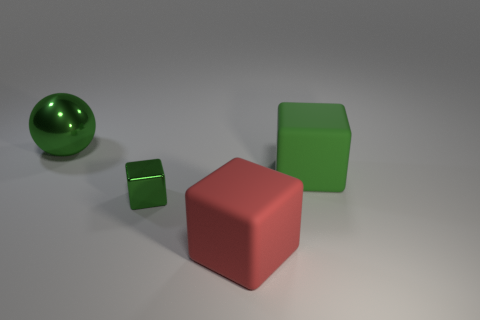Subtract all green blocks. How many blocks are left? 1 Add 1 green cubes. How many objects exist? 5 Subtract all blue cylinders. How many green cubes are left? 2 Subtract all balls. How many objects are left? 3 Subtract all red cubes. How many cubes are left? 2 Add 4 tiny yellow metallic cylinders. How many tiny yellow metallic cylinders exist? 4 Subtract 0 green cylinders. How many objects are left? 4 Subtract all brown balls. Subtract all cyan cylinders. How many balls are left? 1 Subtract all large metallic objects. Subtract all small red shiny balls. How many objects are left? 3 Add 3 red blocks. How many red blocks are left? 4 